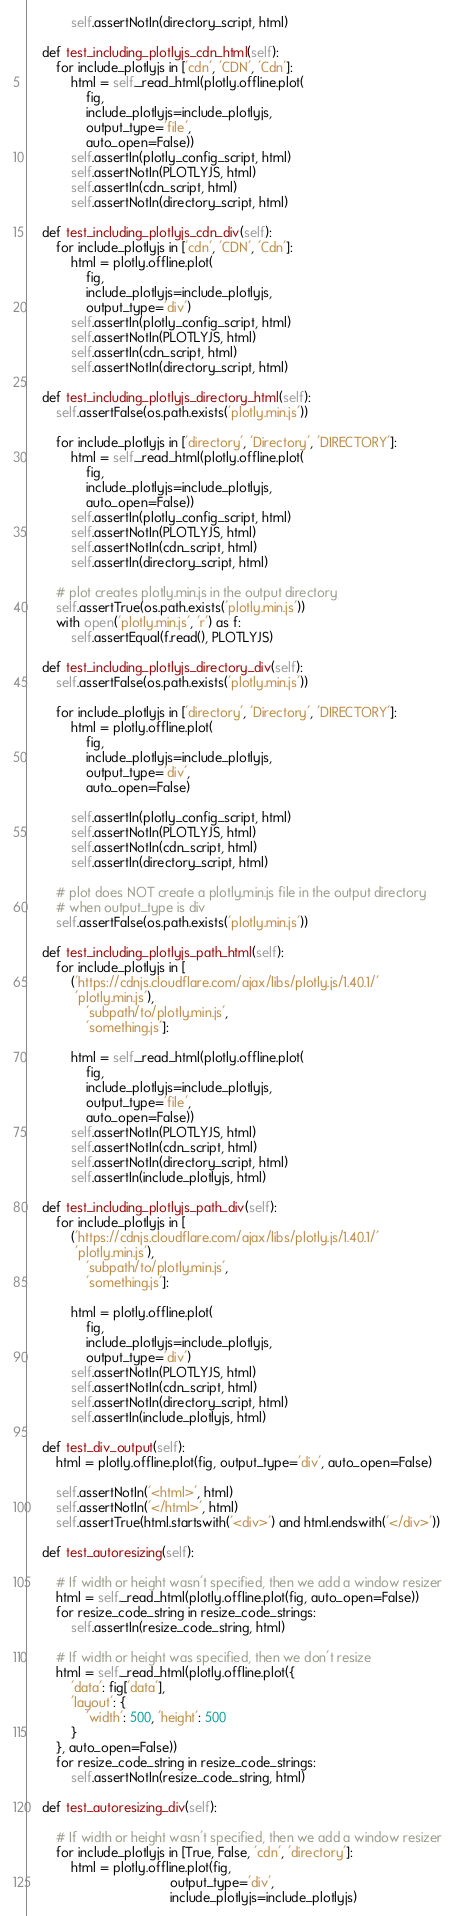Convert code to text. <code><loc_0><loc_0><loc_500><loc_500><_Python_>            self.assertNotIn(directory_script, html)

    def test_including_plotlyjs_cdn_html(self):
        for include_plotlyjs in ['cdn', 'CDN', 'Cdn']:
            html = self._read_html(plotly.offline.plot(
                fig,
                include_plotlyjs=include_plotlyjs,
                output_type='file',
                auto_open=False))
            self.assertIn(plotly_config_script, html)
            self.assertNotIn(PLOTLYJS, html)
            self.assertIn(cdn_script, html)
            self.assertNotIn(directory_script, html)

    def test_including_plotlyjs_cdn_div(self):
        for include_plotlyjs in ['cdn', 'CDN', 'Cdn']:
            html = plotly.offline.plot(
                fig,
                include_plotlyjs=include_plotlyjs,
                output_type='div')
            self.assertIn(plotly_config_script, html)
            self.assertNotIn(PLOTLYJS, html)
            self.assertIn(cdn_script, html)
            self.assertNotIn(directory_script, html)

    def test_including_plotlyjs_directory_html(self):
        self.assertFalse(os.path.exists('plotly.min.js'))

        for include_plotlyjs in ['directory', 'Directory', 'DIRECTORY']:
            html = self._read_html(plotly.offline.plot(
                fig,
                include_plotlyjs=include_plotlyjs,
                auto_open=False))
            self.assertIn(plotly_config_script, html)
            self.assertNotIn(PLOTLYJS, html)
            self.assertNotIn(cdn_script, html)
            self.assertIn(directory_script, html)

        # plot creates plotly.min.js in the output directory
        self.assertTrue(os.path.exists('plotly.min.js'))
        with open('plotly.min.js', 'r') as f:
            self.assertEqual(f.read(), PLOTLYJS)

    def test_including_plotlyjs_directory_div(self):
        self.assertFalse(os.path.exists('plotly.min.js'))

        for include_plotlyjs in ['directory', 'Directory', 'DIRECTORY']:
            html = plotly.offline.plot(
                fig,
                include_plotlyjs=include_plotlyjs,
                output_type='div',
                auto_open=False)

            self.assertIn(plotly_config_script, html)
            self.assertNotIn(PLOTLYJS, html)
            self.assertNotIn(cdn_script, html)
            self.assertIn(directory_script, html)

        # plot does NOT create a plotly.min.js file in the output directory
        # when output_type is div
        self.assertFalse(os.path.exists('plotly.min.js'))

    def test_including_plotlyjs_path_html(self):
        for include_plotlyjs in [
            ('https://cdnjs.cloudflare.com/ajax/libs/plotly.js/1.40.1/'
             'plotly.min.js'),
                'subpath/to/plotly.min.js',
                'something.js']:

            html = self._read_html(plotly.offline.plot(
                fig,
                include_plotlyjs=include_plotlyjs,
                output_type='file',
                auto_open=False))
            self.assertNotIn(PLOTLYJS, html)
            self.assertNotIn(cdn_script, html)
            self.assertNotIn(directory_script, html)
            self.assertIn(include_plotlyjs, html)

    def test_including_plotlyjs_path_div(self):
        for include_plotlyjs in [
            ('https://cdnjs.cloudflare.com/ajax/libs/plotly.js/1.40.1/'
             'plotly.min.js'),
                'subpath/to/plotly.min.js',
                'something.js']:

            html = plotly.offline.plot(
                fig,
                include_plotlyjs=include_plotlyjs,
                output_type='div')
            self.assertNotIn(PLOTLYJS, html)
            self.assertNotIn(cdn_script, html)
            self.assertNotIn(directory_script, html)
            self.assertIn(include_plotlyjs, html)

    def test_div_output(self):
        html = plotly.offline.plot(fig, output_type='div', auto_open=False)

        self.assertNotIn('<html>', html)
        self.assertNotIn('</html>', html)
        self.assertTrue(html.startswith('<div>') and html.endswith('</div>'))

    def test_autoresizing(self):

        # If width or height wasn't specified, then we add a window resizer
        html = self._read_html(plotly.offline.plot(fig, auto_open=False))
        for resize_code_string in resize_code_strings:
            self.assertIn(resize_code_string, html)

        # If width or height was specified, then we don't resize
        html = self._read_html(plotly.offline.plot({
            'data': fig['data'],
            'layout': {
                'width': 500, 'height': 500
            }
        }, auto_open=False))
        for resize_code_string in resize_code_strings:
            self.assertNotIn(resize_code_string, html)

    def test_autoresizing_div(self):

        # If width or height wasn't specified, then we add a window resizer
        for include_plotlyjs in [True, False, 'cdn', 'directory']:
            html = plotly.offline.plot(fig,
                                       output_type='div',
                                       include_plotlyjs=include_plotlyjs)
</code> 